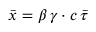<formula> <loc_0><loc_0><loc_500><loc_500>\bar { x } = \beta \, \gamma \cdot c \, \bar { \tau }</formula> 